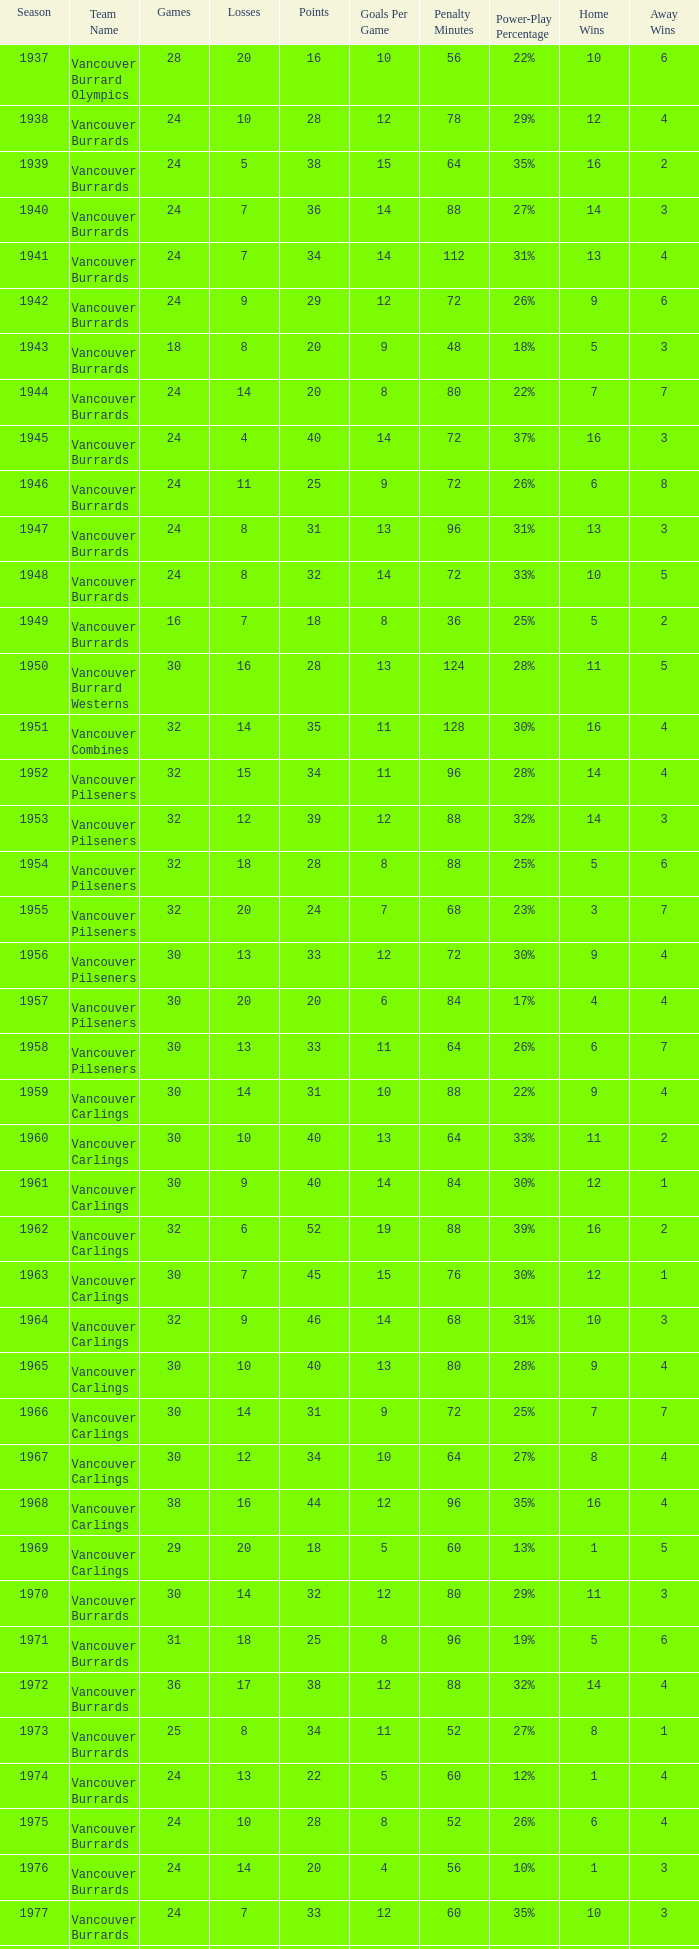What's the total number of points when the vancouver carlings have fewer than 12 losses and more than 32 games? 0.0. 